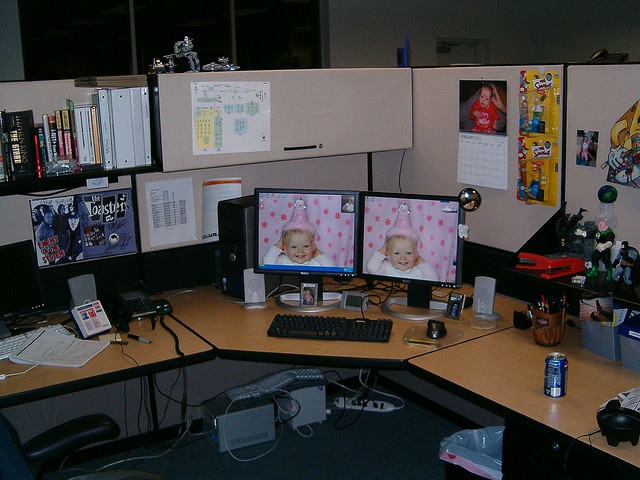Describe the objects in this image and their specific colors. I can see tv in black and gray tones, tv in black and gray tones, book in black, darkgray, gray, and tan tones, chair in black, darkblue, and blue tones, and keyboard in black, maroon, and gray tones in this image. 